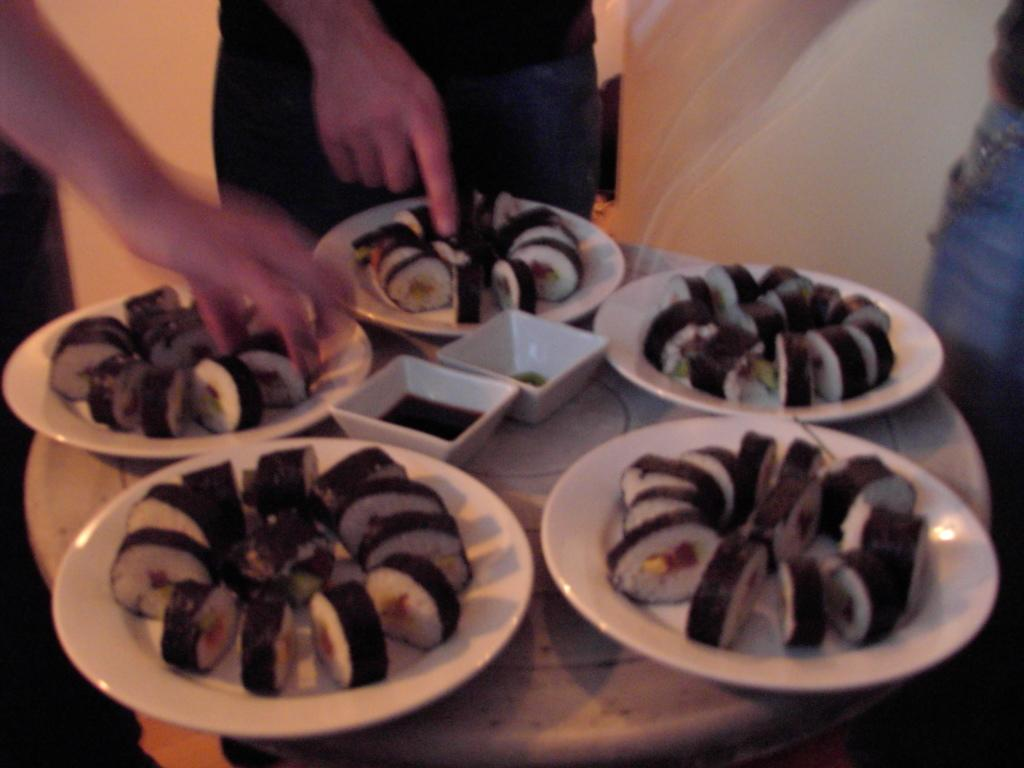What is present on the plates in the image? There are food items on plates in the image. What type of tableware can be seen on the table? There are bowls on a table in the image. Can you describe the people in the image? There is a group of people standing in the image. What time of day is depicted in the image? The time of day is not mentioned or depicted in the image. Can you see any chickens in the image? There are no chickens present in the image. 